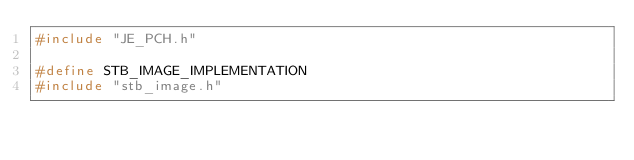Convert code to text. <code><loc_0><loc_0><loc_500><loc_500><_C++_>#include "JE_PCH.h"

#define STB_IMAGE_IMPLEMENTATION
#include "stb_image.h"</code> 